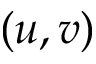Convert formula to latex. <formula><loc_0><loc_0><loc_500><loc_500>( u , v )</formula> 